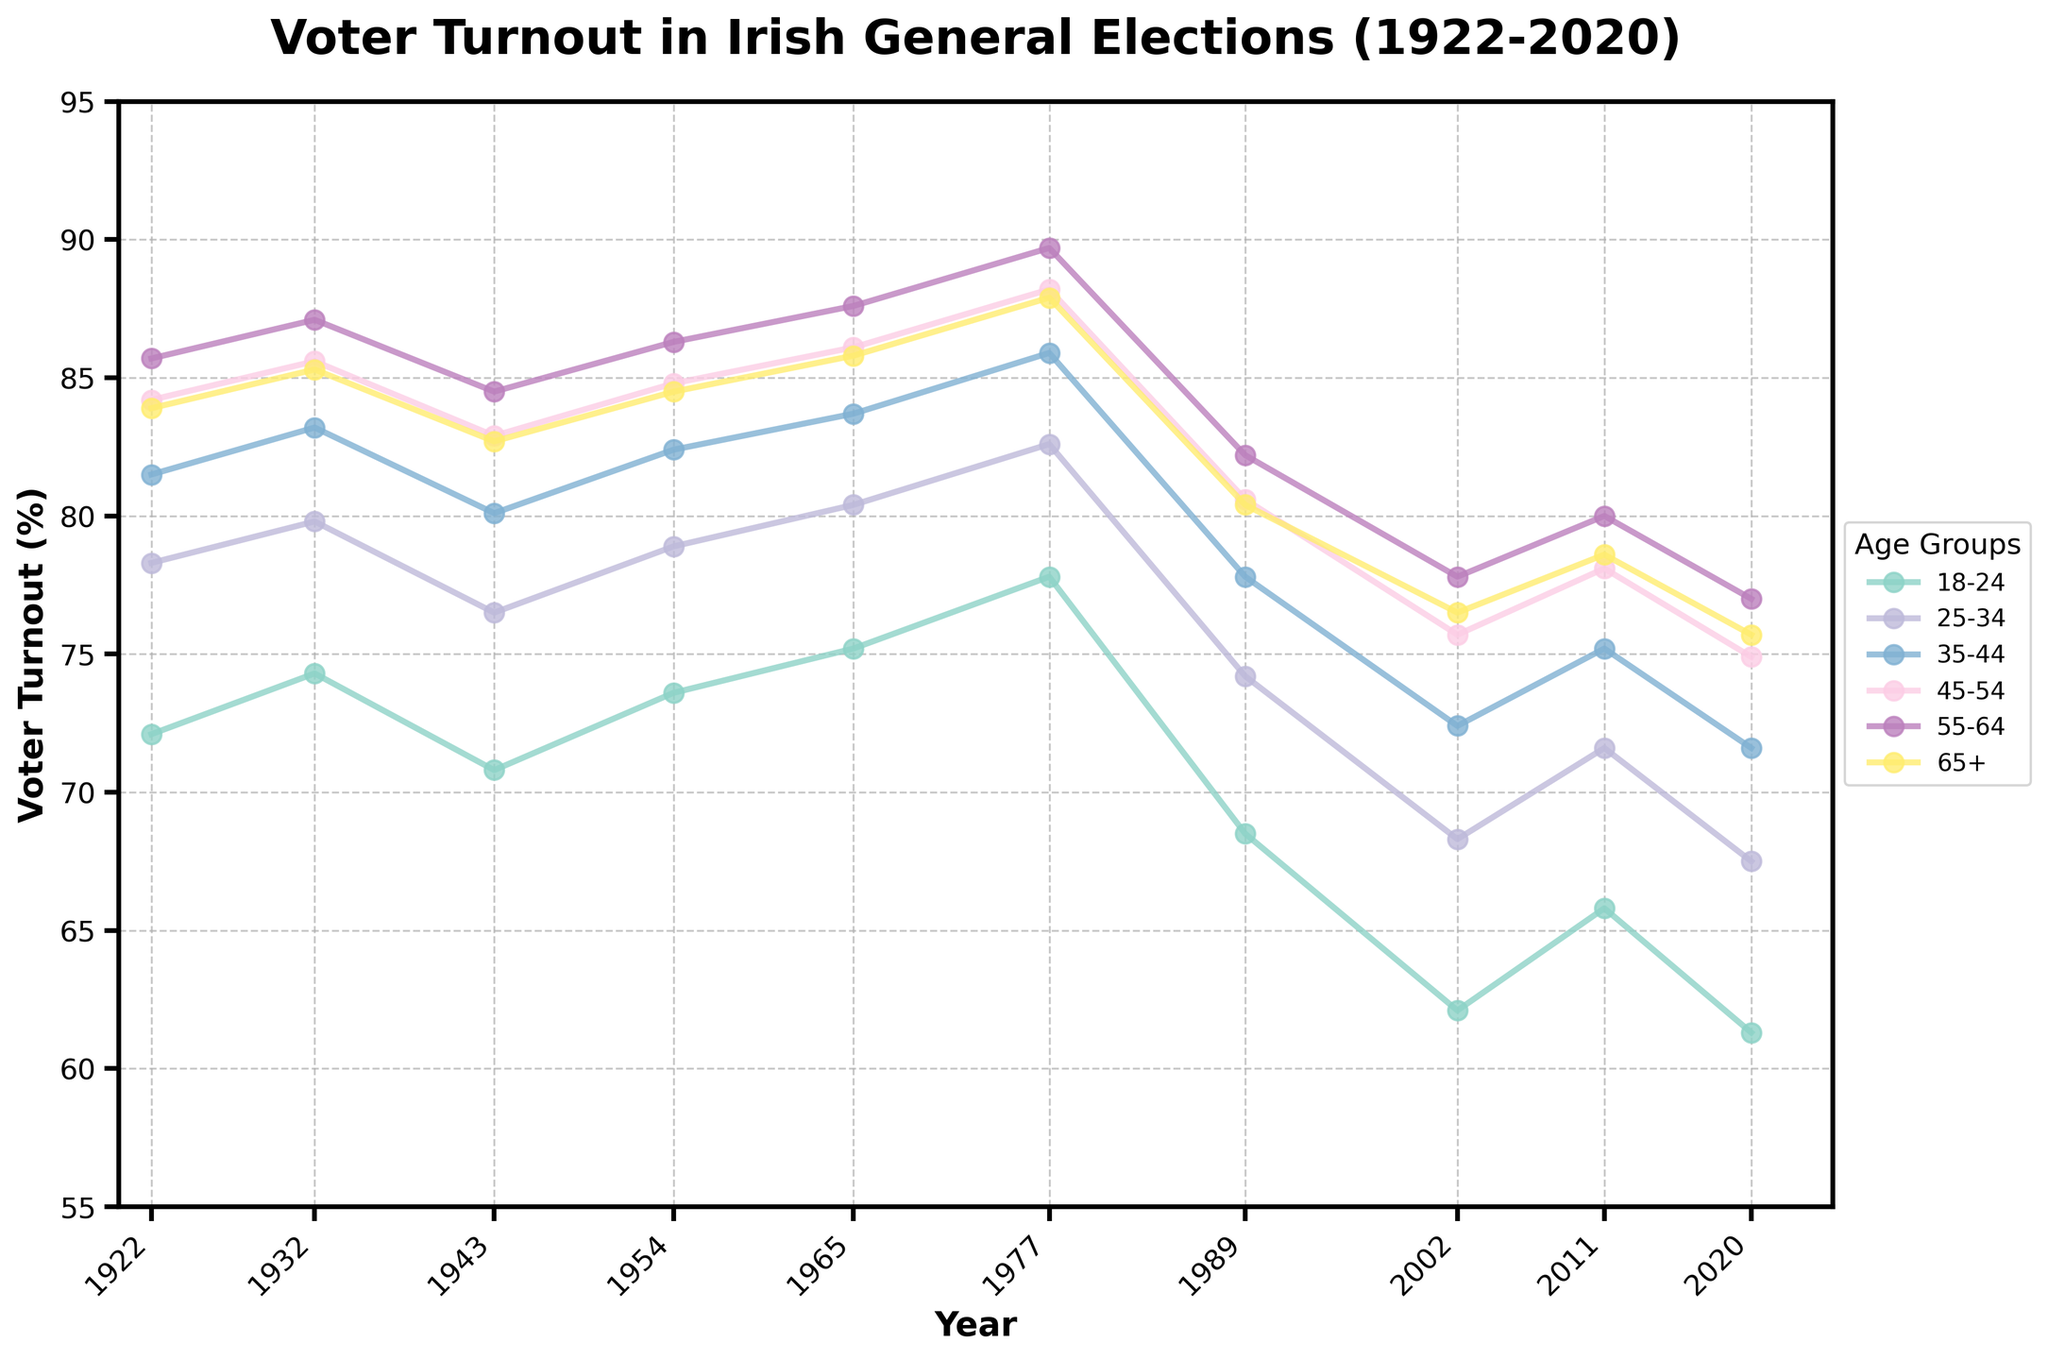What's the average voter turnout of the 18-24 age group over the years? Add the voter turnout percentages for the 18-24 age group across all years: 72.1 + 74.3 + 70.8 + 73.6 + 75.2 + 77.8 + 68.5 + 62.1 + 65.8 + 61.3 = 701.5. There are 10 years, so divide the sum by 10: 701.5 / 10 = 70.15.
Answer: 70.15 Which age group had the highest voter turnout in 2020? Compare the voter turnout percentages for each age group in the year 2020: 18-24 (61.3), 25-34 (67.5), 35-44 (71.6), 45-54 (74.9), 55-64 (77.0), 65+ (75.7). The highest value is 77.0 for the 55-64 age group.
Answer: 55-64 Did the voter turnout for the 45-54 age group increase or decrease from 1922 to 2020? Look at the voter turnout for the 45-54 age group in the years 1922 (84.2) and 2020 (74.9). Since 74.9 is less than 84.2, the voter turnout decreased.
Answer: Decrease What is the difference in voter turnout between the 18-24 and 65+ age groups in 1977? Find the voter turnout for the 18-24 (77.8) and 65+ (87.9) age groups in 1977. Subtract the 18-24 turnout from the 65+ turnout: 87.9 - 77.8 = 10.1.
Answer: 10.1 Which year had the lowest voter turnout for the 25-34 age group? Compare the voter turnout percentages for the 25-34 age group across all years: 1922 (78.3), 1932 (79.8), 1943 (76.5), 1954 (78.9), 1965 (80.4), 1977 (82.6), 1989 (74.2), 2002 (68.3), 2011 (71.6), 2020 (67.5). The lowest value is 67.5 in the year 2020.
Answer: 2020 Which age group has shown the most significant decrease in voter turnout from its highest point to 2020? Identify the highest voter turnout and the turnout in 2020 for each age group. Calculate the difference for each:
- 18-24: max (77.8) - 2020 (61.3) = 16.5
- 25-34: max (82.6) - 2020 (67.5) = 15.1
- 35-44: max (85.9) - 2020 (71.6) = 14.3
- 45-54: max (88.2) - 2020 (74.9) = 13.3
- 55-64: max (89.7) - 2020 (77.0) = 12.7
- 65+: max (87.9) - 2020 (75.7) = 12.2
The most significant decrease is 16.5 for the 18-24 age group.
Answer: 18-24 Has any age group recorded a voter turnout below 60%? Scan the data for all age groups across all years to see if any value is below 60%. The lowest recorded turnout is 61.3 for the 18-24 age group in 2020, which is above 60%. Therefore, no age group has recorded a turnout below 60%.
Answer: No Which age group had the most stable voter turnout from 1922 to 2020? Evaluate the fluctuation for each age group by looking at the range (highest value minus lowest value):
- 18-24: 77.8 - 61.3 = 16.5
- 25-34: 82.6 - 67.5 = 15.1
- 35-44: 85.9 - 71.6 = 14.3
- 45-54: 88.2 - 74.9 = 13.3
- 55-64: 89.7 - 77.0 = 12.7
- 65+: 87.9 - 75.7 = 12.2
The 65+ age group has the smallest range, indicating it had the most stable voter turnout.
Answer: 65+ 